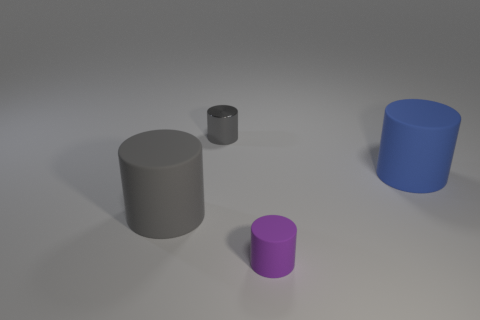Subtract all cyan spheres. How many gray cylinders are left? 2 Subtract all tiny purple cylinders. How many cylinders are left? 3 Subtract all blue cylinders. How many cylinders are left? 3 Subtract 1 cylinders. How many cylinders are left? 3 Add 3 tiny purple matte cubes. How many objects exist? 7 Subtract all green cylinders. Subtract all red balls. How many cylinders are left? 4 Subtract 0 purple balls. How many objects are left? 4 Subtract all red metal cubes. Subtract all purple rubber objects. How many objects are left? 3 Add 4 large gray cylinders. How many large gray cylinders are left? 5 Add 4 big cyan shiny cylinders. How many big cyan shiny cylinders exist? 4 